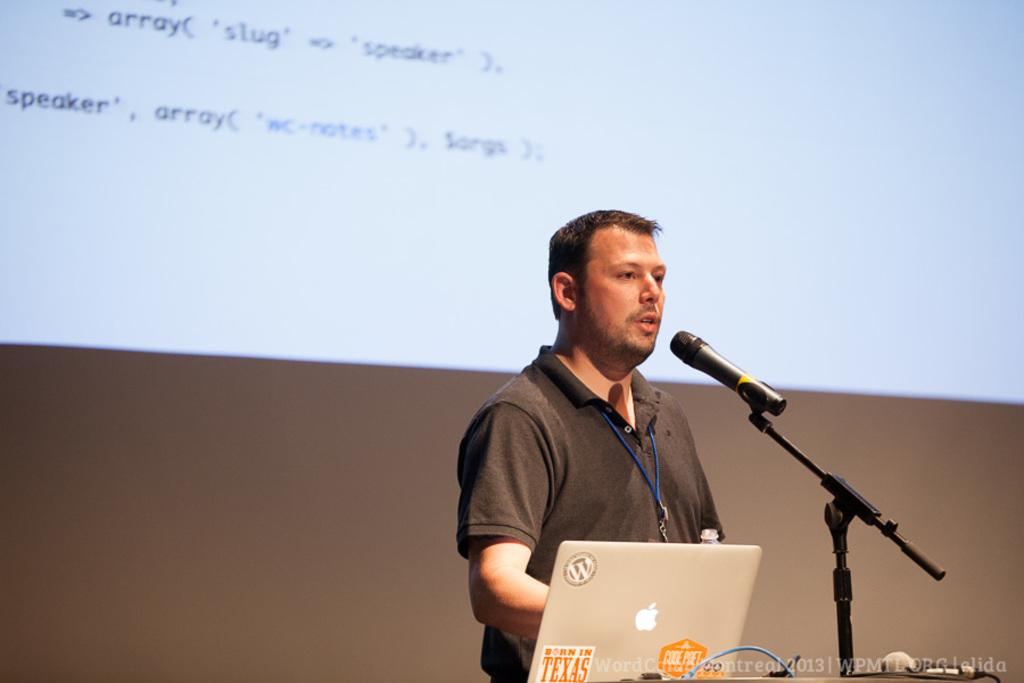What is the man in the image doing? The man is speaking on the microphone. What is the man wearing? The man is wearing a black color t-shirt. What electronic device can be seen in the image? There is a laptop in the image. What is located behind the man? There is a projector screen behind the man. Can you see any beans on the projector screen in the image? There are no beans present on the projector screen in the image. What type of waves can be seen crashing on the shore in the image? There is no shore or waves depicted in the image; it features a man speaking on the microphone, a laptop, and a projector screen. 